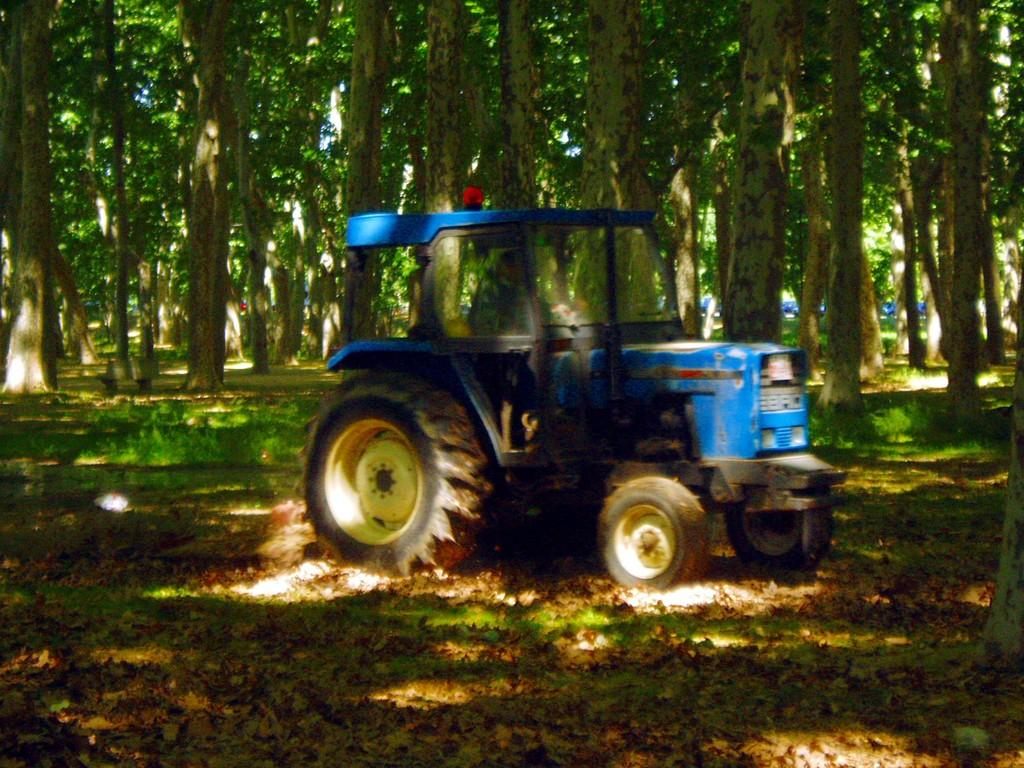What is the main subject of the picture? The main subject of the picture is a tractor. What type of vegetation can be seen in the picture? There are trees in the picture. What is the ground covered with in the picture? There is grass on the ground in the picture. What book is the farmer reading while operating the tractor in the picture? There is no farmer or book present in the picture; it features a tractor and natural elements. What type of gardening tool is being used by the person in the picture? There is no person or gardening tool present in the picture; it features a tractor and natural elements. 